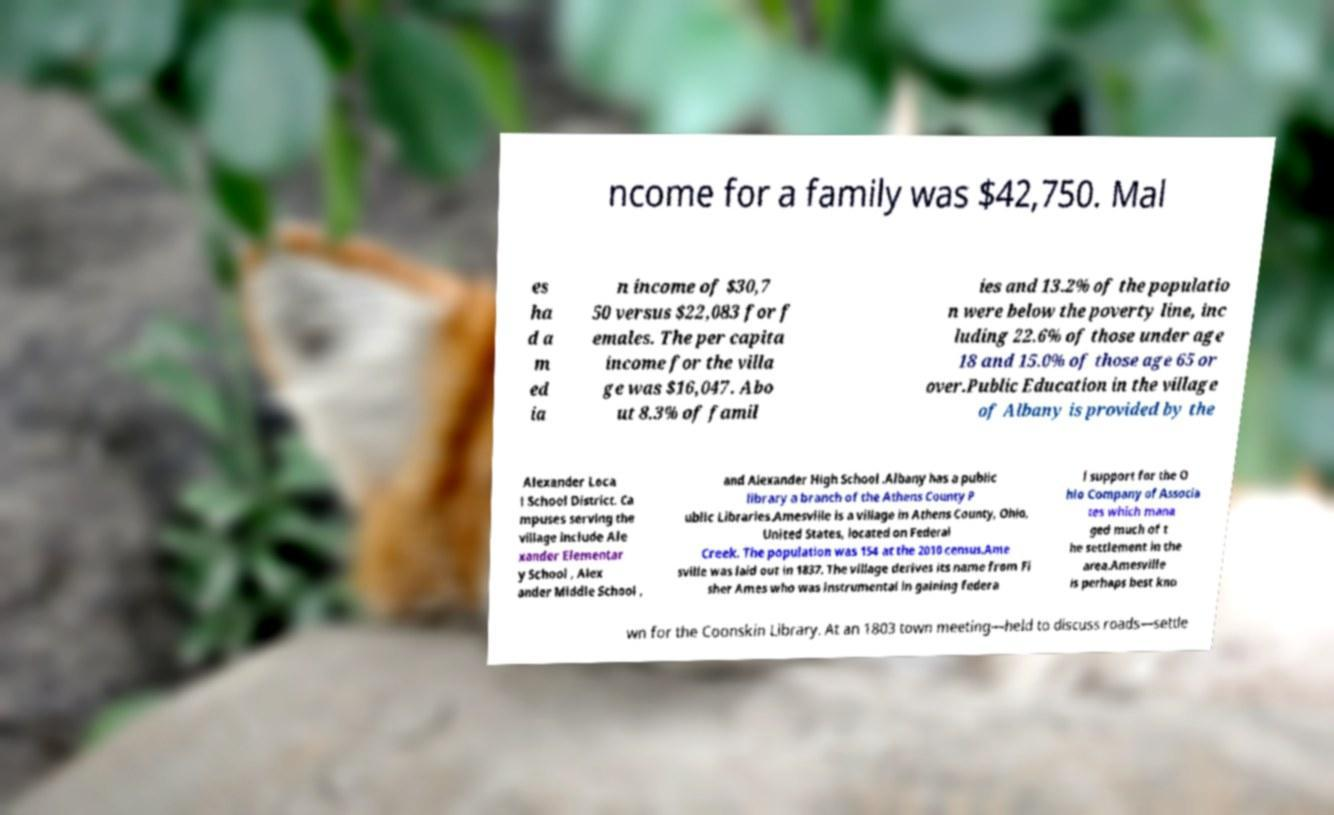I need the written content from this picture converted into text. Can you do that? ncome for a family was $42,750. Mal es ha d a m ed ia n income of $30,7 50 versus $22,083 for f emales. The per capita income for the villa ge was $16,047. Abo ut 8.3% of famil ies and 13.2% of the populatio n were below the poverty line, inc luding 22.6% of those under age 18 and 15.0% of those age 65 or over.Public Education in the village of Albany is provided by the Alexander Loca l School District. Ca mpuses serving the village include Ale xander Elementar y School , Alex ander Middle School , and Alexander High School .Albany has a public library a branch of the Athens County P ublic Libraries.Amesville is a village in Athens County, Ohio, United States, located on Federal Creek. The population was 154 at the 2010 census.Ame sville was laid out in 1837. The village derives its name from Fi sher Ames who was instrumental in gaining federa l support for the O hio Company of Associa tes which mana ged much of t he settlement in the area.Amesville is perhaps best kno wn for the Coonskin Library. At an 1803 town meeting—held to discuss roads—settle 